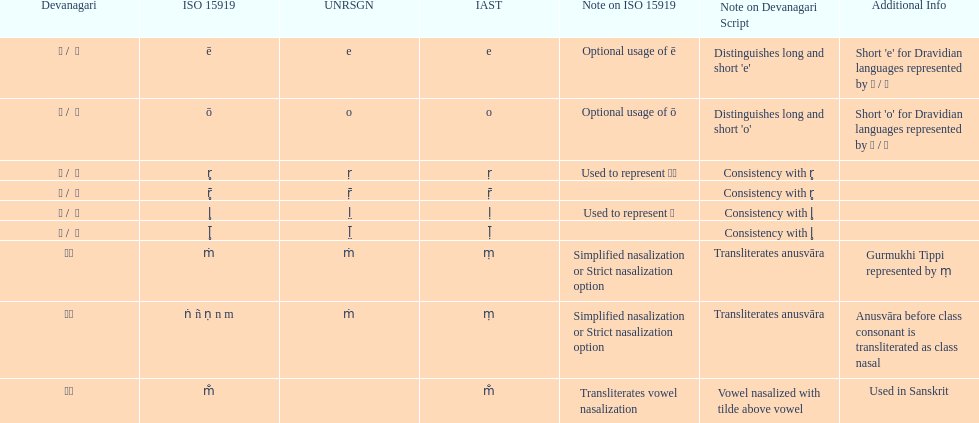Which devanagaria means the same as this iast letter: o? ओ / ो. 